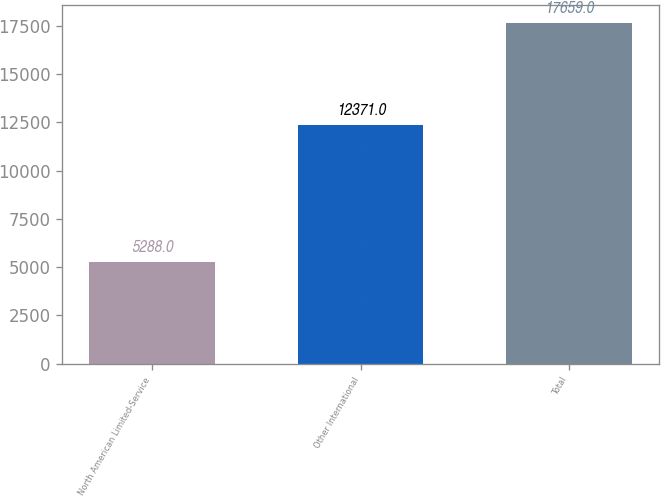Convert chart. <chart><loc_0><loc_0><loc_500><loc_500><bar_chart><fcel>North American Limited-Service<fcel>Other International<fcel>Total<nl><fcel>5288<fcel>12371<fcel>17659<nl></chart> 